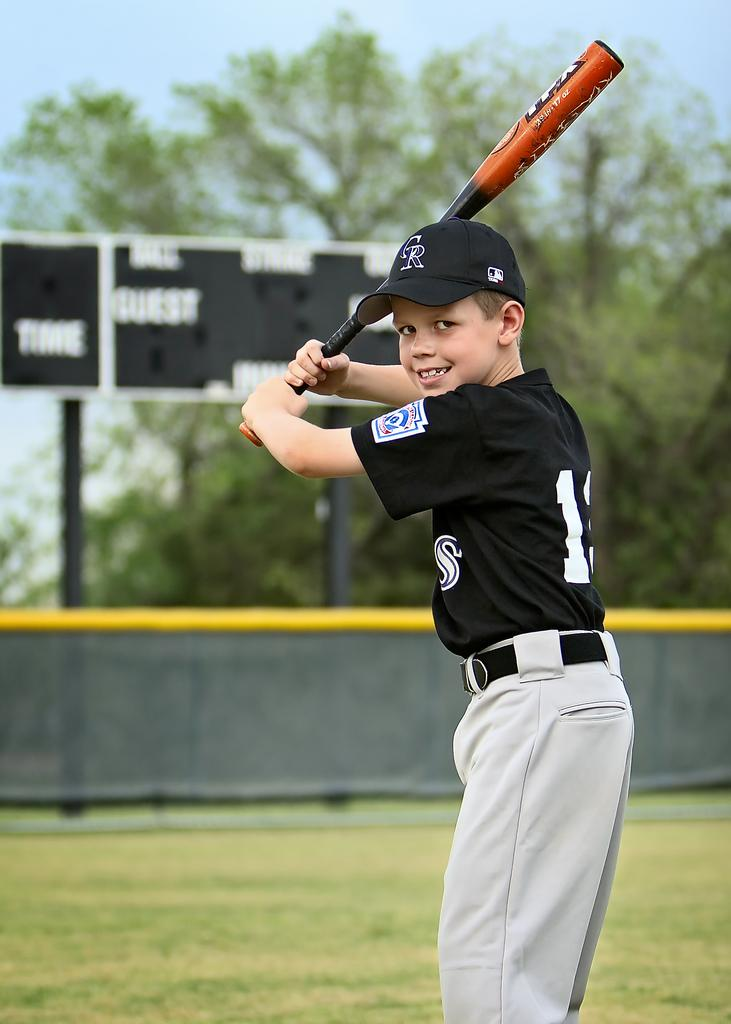<image>
Summarize the visual content of the image. A boy in a CR hat holds his baseball bat up and smiles for a photo. 